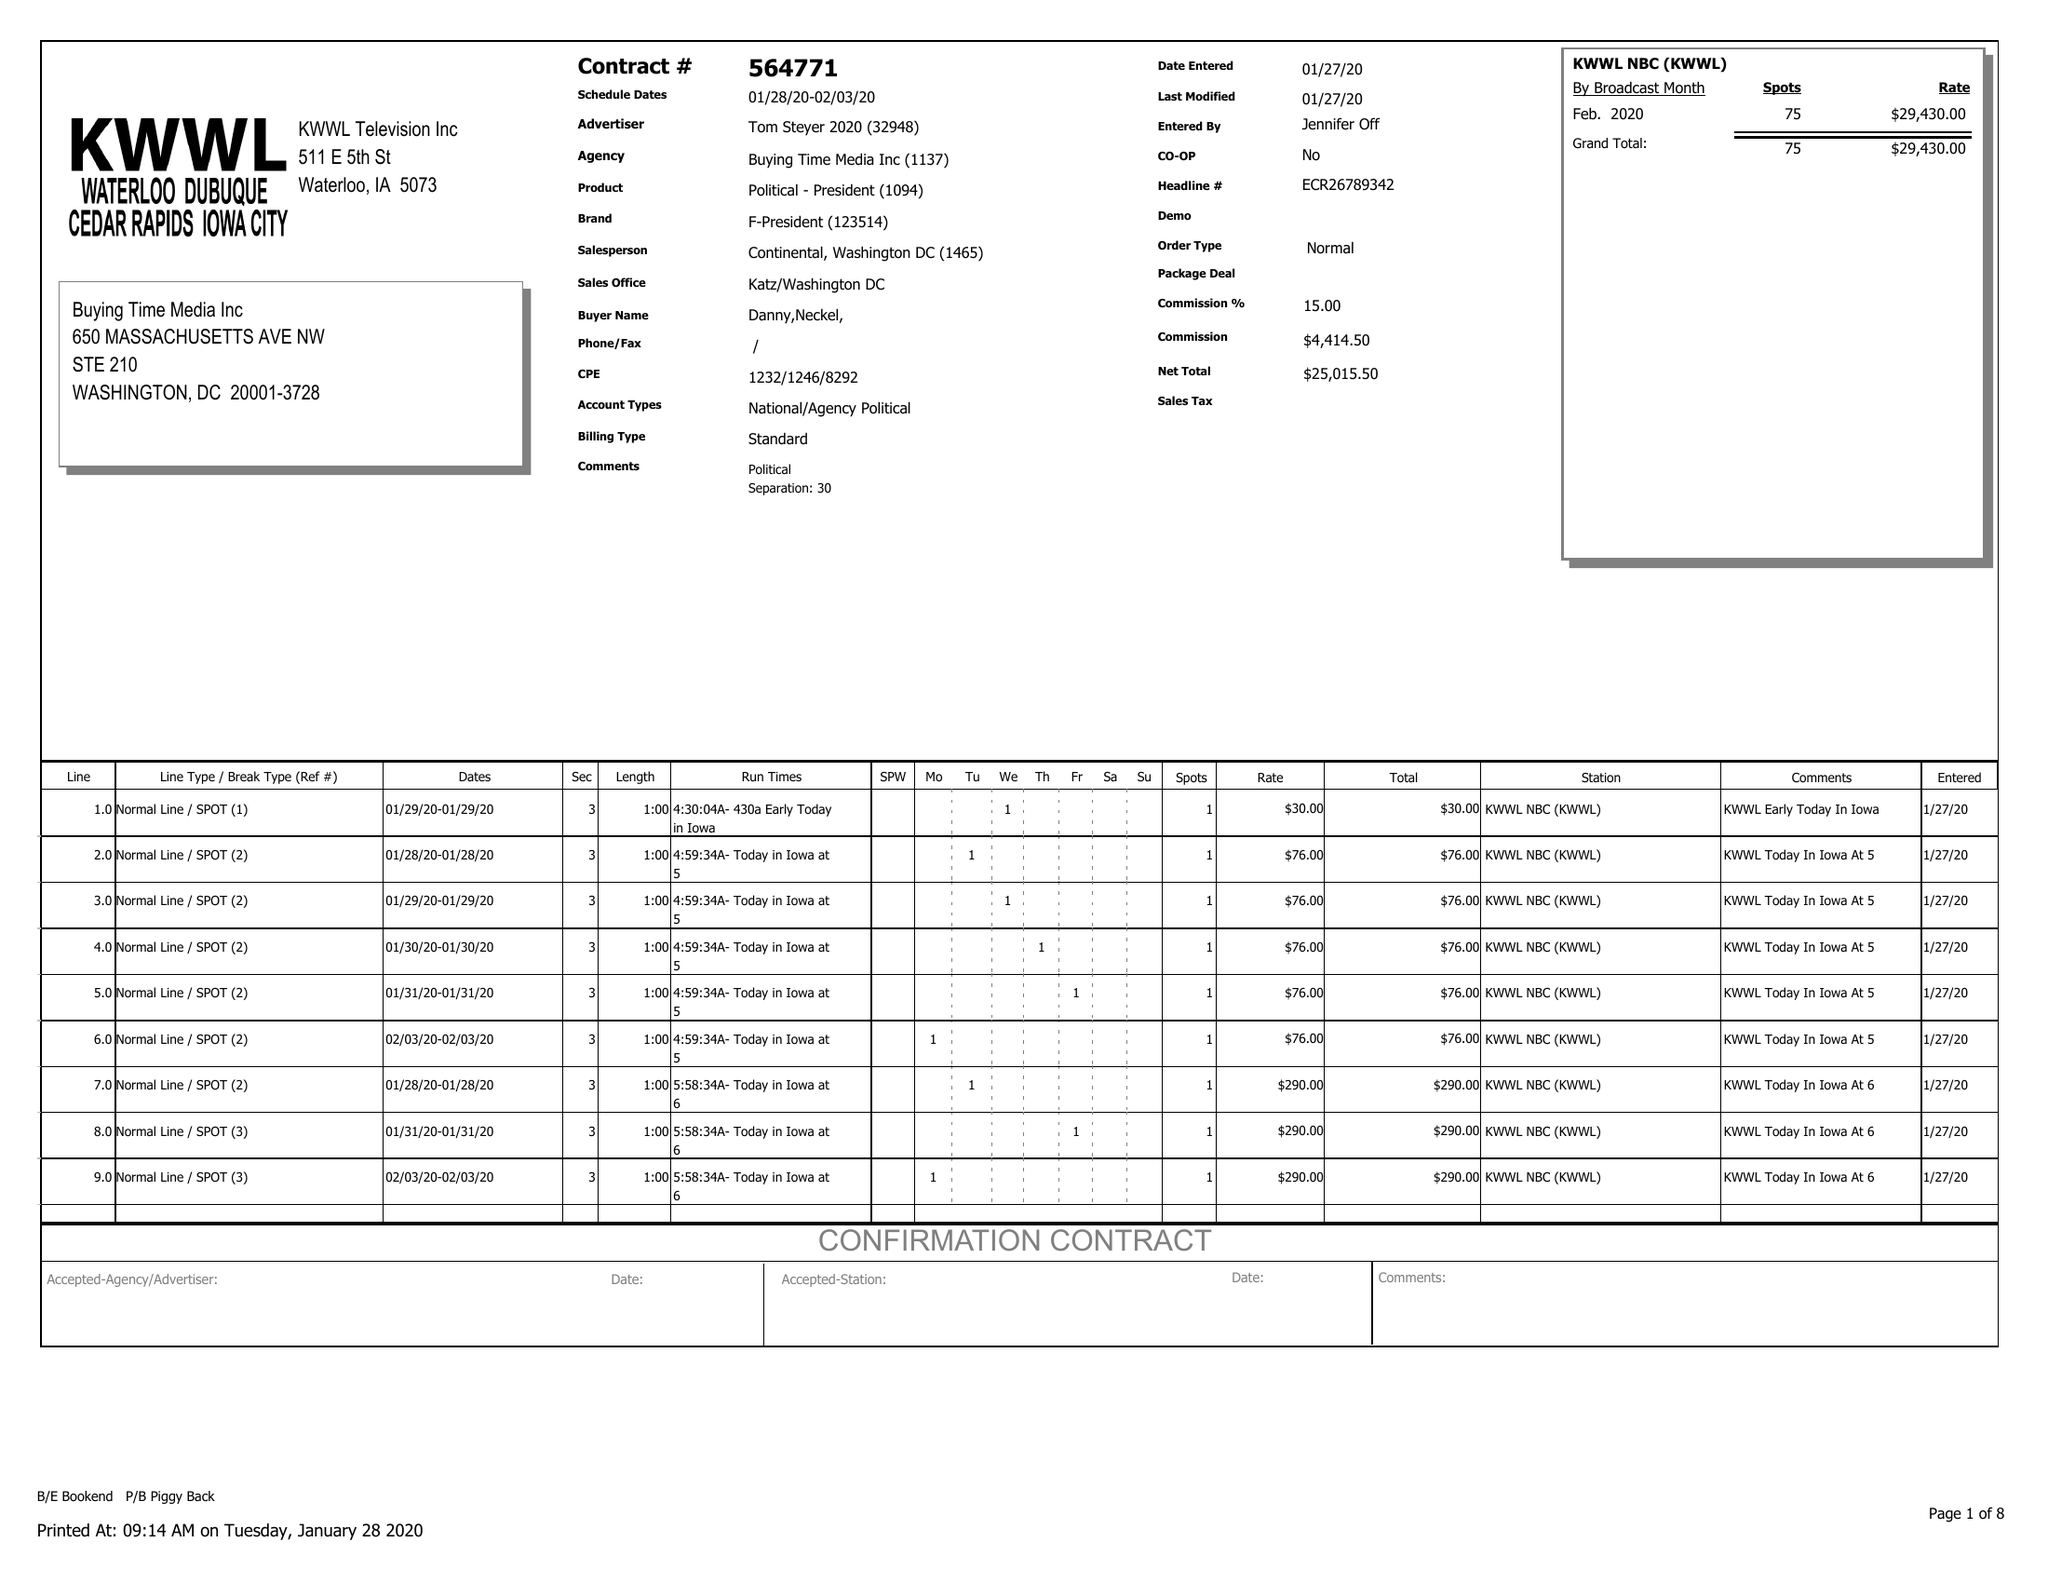What is the value for the gross_amount?
Answer the question using a single word or phrase. 29430.00 